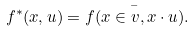Convert formula to latex. <formula><loc_0><loc_0><loc_500><loc_500>f ^ { * } ( x , u ) = \bar { f ( x \in v , x \cdot u ) } .</formula> 